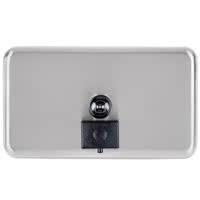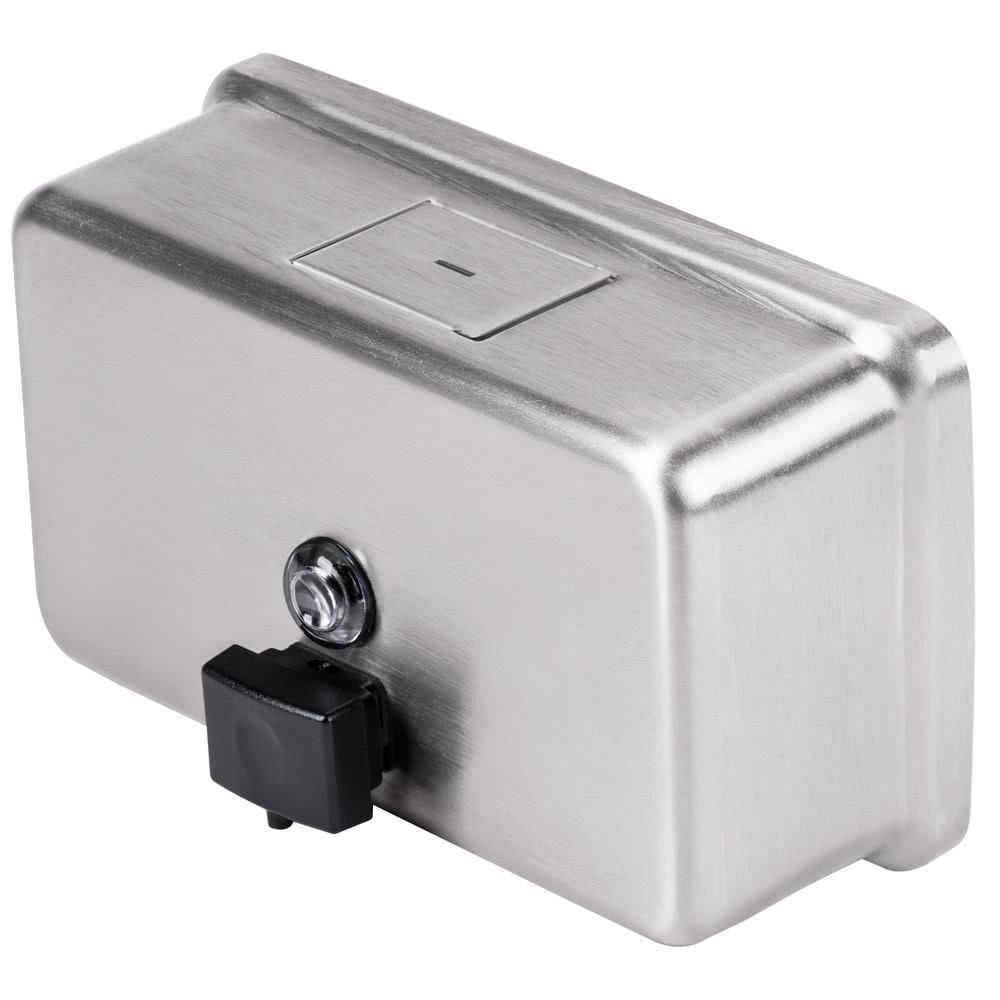The first image is the image on the left, the second image is the image on the right. Examine the images to the left and right. Is the description "The object in the image on the left is turned toward the right." accurate? Answer yes or no. No. 